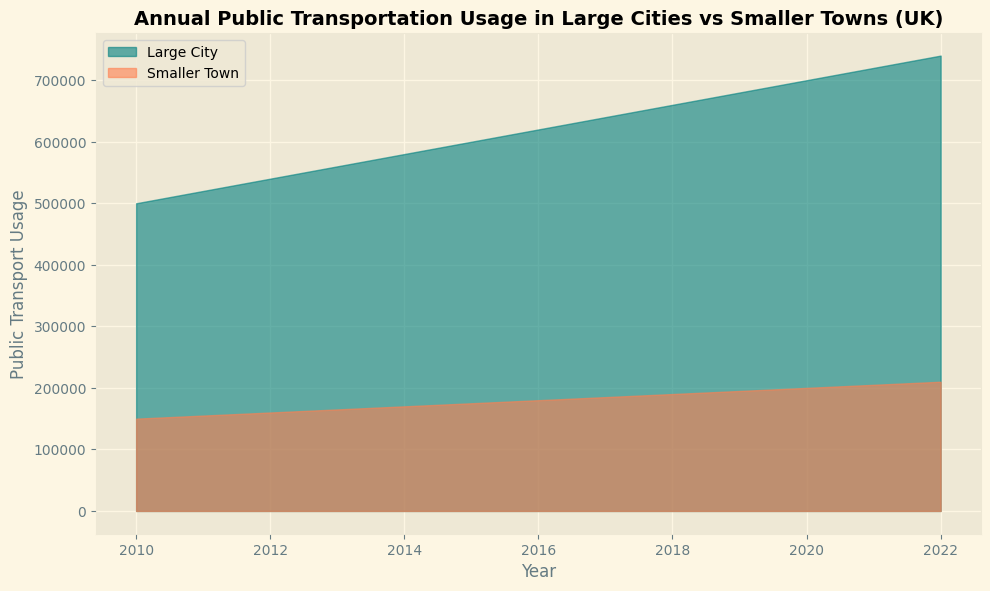What's the average annual public transport usage for large cities between 2010 and 2015? First, note the values for large cities between 2010 and 2015: 500000, 520000, 540000, 560000, 580000, 600000. Sum these up: 500000 + 520000 + 540000 + 560000 + 580000 + 600000 = 3300000. There are 6 values, so the average is 3300000 / 6 = 550000.
Answer: 550000 Which city type had the highest public transport usage in 2017? Find the values for both city types in 2017. Large City has 640000 and Smaller Town has 185000. Comparing these, the Large City has the higher value.
Answer: Large City What is the difference in public transport usage between large cities and smaller towns in 2022? Note the values for each city type in 2022: Large City has 740000 and Smaller Town has 210000. The difference is 740000 - 210000 = 530000.
Answer: 530000 How much did public transport usage increase in smaller towns from 2010 to 2022? Note the values for smaller towns in 2010 and 2022: 150000 and 210000, respectively. The increase is 210000 - 150000 = 60000.
Answer: 60000 In which year was the difference between public transport usage in large cities and smaller towns the smallest? Calculate the differences for each year. The smallest difference occurs in 2010 with a difference of 500000 - 150000 = 350000, which is smaller than the differences for other years.
Answer: 2010 By how much did public transport usage increase in large cities from 2010 to 2020? Note the values for large cities in 2010 and 2020: 500000 and 700000, respectively. The increase is 700000 - 500000 = 200000.
Answer: 200000 In which year did smaller towns first reach a public transport usage of 200000? Look for the first year smaller towns had a value of 200000: it happened in 2020.
Answer: 2020 What was the average annual increase in public transport usage for large cities from 2010 to 2022? Find the total increase from 2010 (500000) to 2022 (740000) which is 740000 - 500000 = 240000. There are 12 intervals from 2010 to 2022, so the average annual increase is 240000 / 12 = 20000.
Answer: 20000 How much more was the transport usage in large cities compared to smaller towns in 2015? Note the values for both city types in 2015: Large City has 600000 and Smaller Town has 175000. The difference is 600000 - 175000 = 425000.
Answer: 425000 